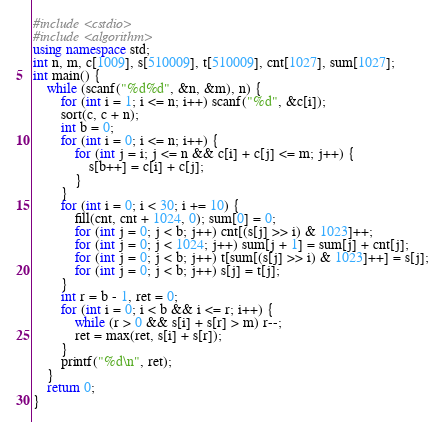<code> <loc_0><loc_0><loc_500><loc_500><_C++_>#include <cstdio>
#include <algorithm>
using namespace std;
int n, m, c[1009], s[510009], t[510009], cnt[1027], sum[1027];
int main() {
	while (scanf("%d%d", &n, &m), n) {
		for (int i = 1; i <= n; i++) scanf("%d", &c[i]);
		sort(c, c + n);
		int b = 0;
		for (int i = 0; i <= n; i++) {
			for (int j = i; j <= n && c[i] + c[j] <= m; j++) {
				s[b++] = c[i] + c[j];
			}
		}
		for (int i = 0; i < 30; i += 10) {
			fill(cnt, cnt + 1024, 0); sum[0] = 0;
			for (int j = 0; j < b; j++) cnt[(s[j] >> i) & 1023]++;
			for (int j = 0; j < 1024; j++) sum[j + 1] = sum[j] + cnt[j];
			for (int j = 0; j < b; j++) t[sum[(s[j] >> i) & 1023]++] = s[j];
			for (int j = 0; j < b; j++) s[j] = t[j];
		}
		int r = b - 1, ret = 0;
		for (int i = 0; i < b && i <= r; i++) {
			while (r > 0 && s[i] + s[r] > m) r--;
			ret = max(ret, s[i] + s[r]);
		}
		printf("%d\n", ret);
	}
	return 0;
}</code> 